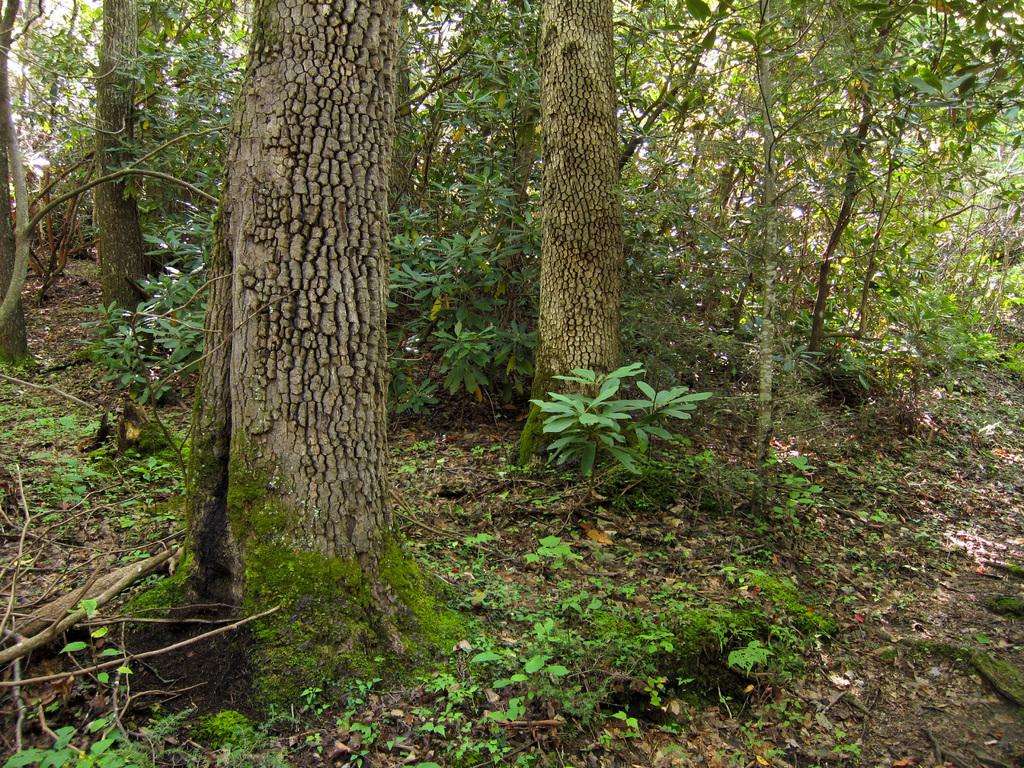What type of vegetation can be seen in the image? There are trees in the image. What colors are present on the trees? The trees have green, brown, and ash colors. What is the color of the ground in the image? The ground is brown in color. What can be seen in the background of the image? The sky is visible in the background of the image. How many geese are resting on the branches of the trees in the image? There are no geese present in the image; it only features trees, ground, and sky. 